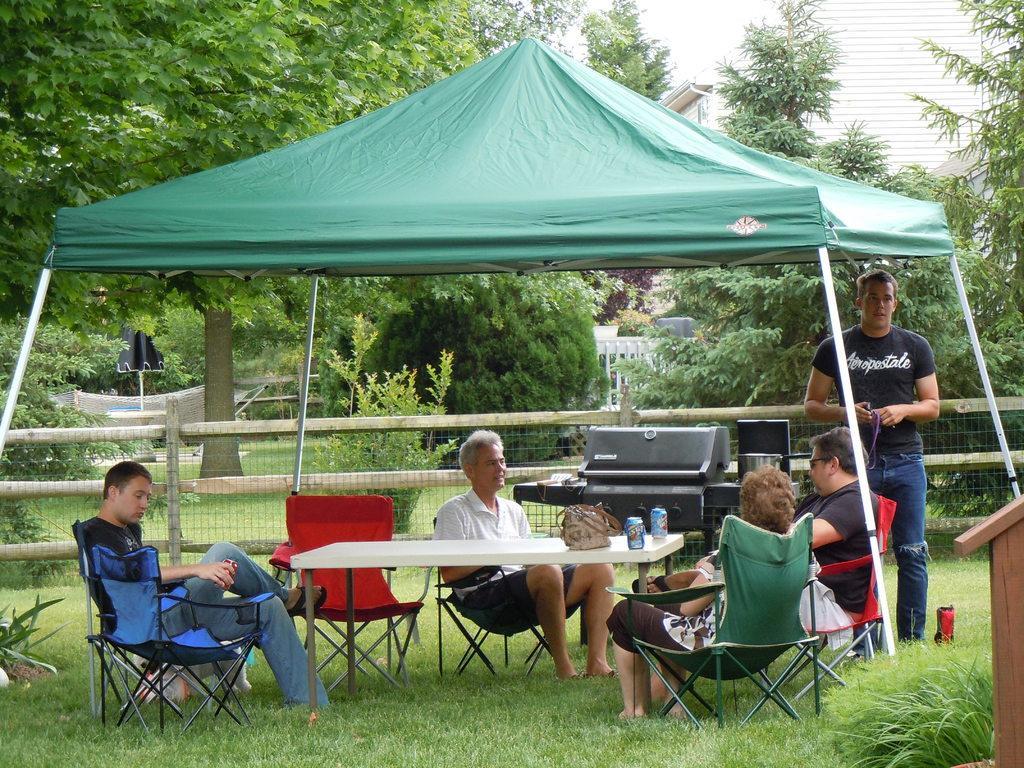Can you describe this image briefly? In this image I can see few people where one man is standing and rest all are sitting on chairs. I can also see a table and on this table I can see a bag and few cans. In the background I can see trees, a building and a tent. 